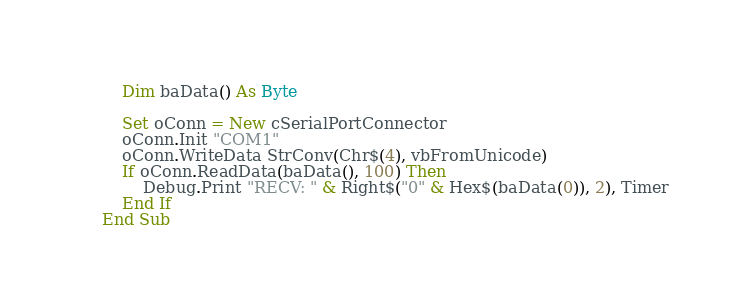<code> <loc_0><loc_0><loc_500><loc_500><_VisualBasic_>    Dim baData() As Byte
    
    Set oConn = New cSerialPortConnector
    oConn.Init "COM1"
    oConn.WriteData StrConv(Chr$(4), vbFromUnicode)
    If oConn.ReadData(baData(), 100) Then
        Debug.Print "RECV: " & Right$("0" & Hex$(baData(0)), 2), Timer
    End If
End Sub
</code> 